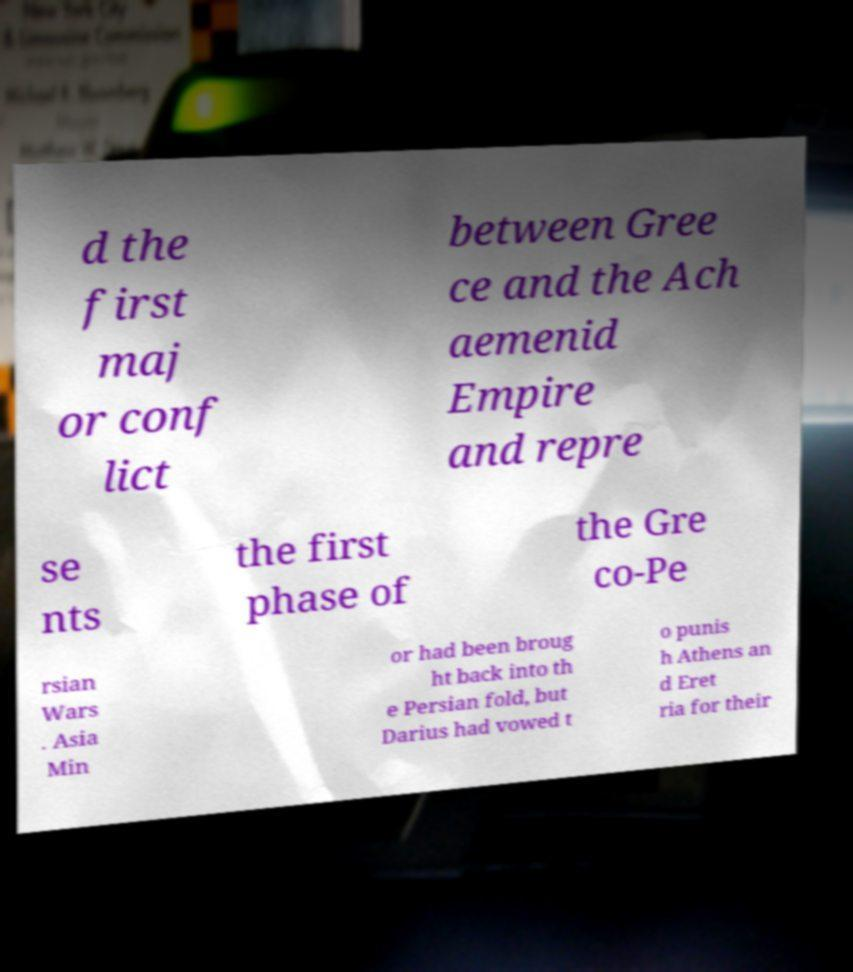I need the written content from this picture converted into text. Can you do that? d the first maj or conf lict between Gree ce and the Ach aemenid Empire and repre se nts the first phase of the Gre co-Pe rsian Wars . Asia Min or had been broug ht back into th e Persian fold, but Darius had vowed t o punis h Athens an d Eret ria for their 